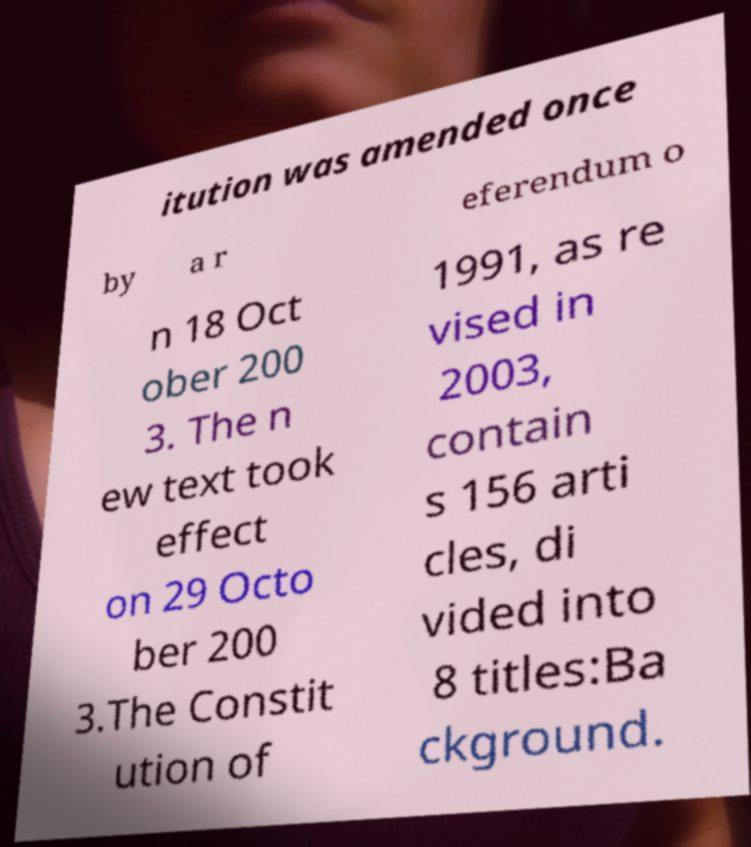I need the written content from this picture converted into text. Can you do that? itution was amended once by a r eferendum o n 18 Oct ober 200 3. The n ew text took effect on 29 Octo ber 200 3.The Constit ution of 1991, as re vised in 2003, contain s 156 arti cles, di vided into 8 titles:Ba ckground. 